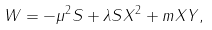Convert formula to latex. <formula><loc_0><loc_0><loc_500><loc_500>W = - \mu ^ { 2 } S + \lambda S X ^ { 2 } + m X Y ,</formula> 